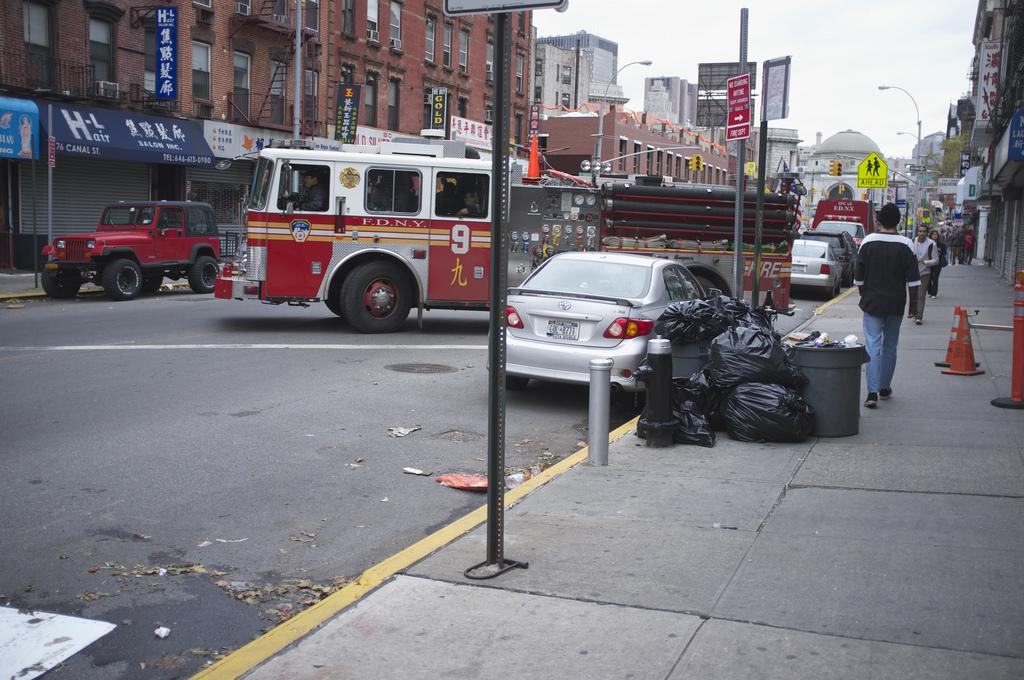State the main color theme of the vehicles and mention a city feature. The main color theme is red, and one noticeable city feature is the presence of a yellow crosswalk. Provide a brief description of the predominant vehicle in the image. A red and white fire truck is parked on the city street with the fireman sitting on the driver side. Identify a safety feature and an unusual item in the image. There are two orange safety cones and a pile of large black garbage bags on the sidewalk. Mention a type of waste and an object denoting a warning in the image. Garbage bags are a type of waste, and the orange traffic cones indicate a warning on the sidewalk. Name a recreational activity and an occupation visible in the image. No recreational activities are visible, but a fireman is present, hinting at his occupation. What is the main mode of transportation seen in the picture and what is a common object? Vehicles, particularly cars, are the main mode of transportation in the image, and trash bags appear to be a common object. Identify an object related to traffic control and a natural element in the image. A yellow traffic light is related to traffic control, and leaves in the street are a natural element. What type of signs can be seen in the image and where are they located? Red street signs on a post, a yellow pedestrian sign, and blue and white signs on windows are visible in the image. Describe the clothing of a person in the image and an animal's presence. A man is wearing a black and white shirt, but there are no visible animals in the picture. Mention the type of weather depicted in the image and a notable color present. The sky appears to be overcast, and there's a noticeable presence of red in the vehicles on the street. 